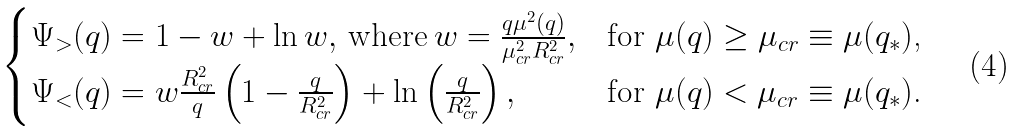<formula> <loc_0><loc_0><loc_500><loc_500>\begin{cases} \Psi _ { > } ( q ) = 1 - w + \ln { w } , \, \text {where} \, w = \frac { q \mu ^ { 2 } ( q ) } { \mu ^ { 2 } _ { c r } R ^ { 2 } _ { c r } } , & \text {for $\mu(q) \geq \mu_{cr}\equiv \mu(q_{*})$,} \\ \Psi _ { < } ( q ) = w \frac { R ^ { 2 } _ { c r } } { q } \left ( 1 - \frac { q } { R _ { c r } ^ { 2 } } \right ) + \ln \left ( \frac { q } { R _ { c r } ^ { 2 } } \right ) , & \text {for $\mu(q)<\mu_{cr}\equiv \mu(q_{*})$.} \end{cases}</formula> 